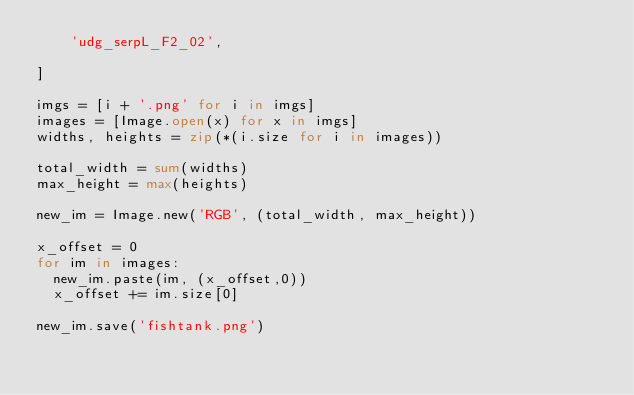Convert code to text. <code><loc_0><loc_0><loc_500><loc_500><_Python_>    'udg_serpL_F2_02',

]

imgs = [i + '.png' for i in imgs]
images = [Image.open(x) for x in imgs]
widths, heights = zip(*(i.size for i in images))

total_width = sum(widths)
max_height = max(heights)

new_im = Image.new('RGB', (total_width, max_height))

x_offset = 0
for im in images:
  new_im.paste(im, (x_offset,0))
  x_offset += im.size[0]

new_im.save('fishtank.png')
</code> 